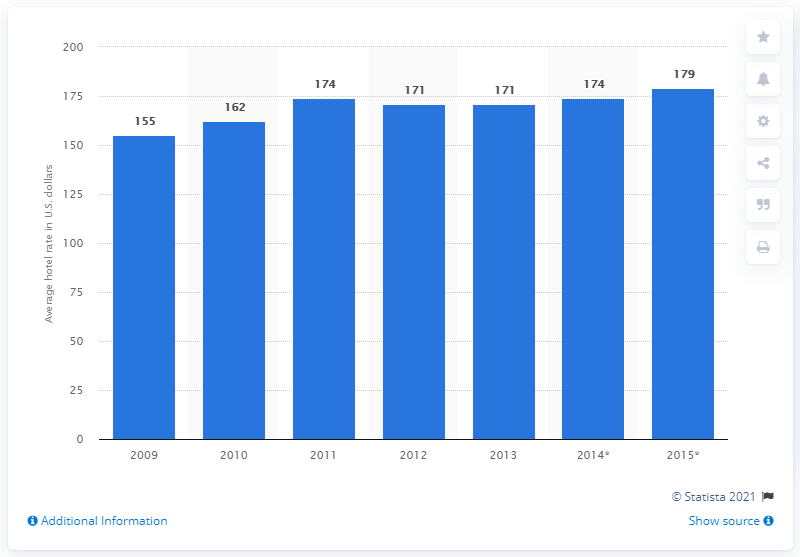Point out several critical features in this image. In 2013, the average global hotel rate was approximately 171. 